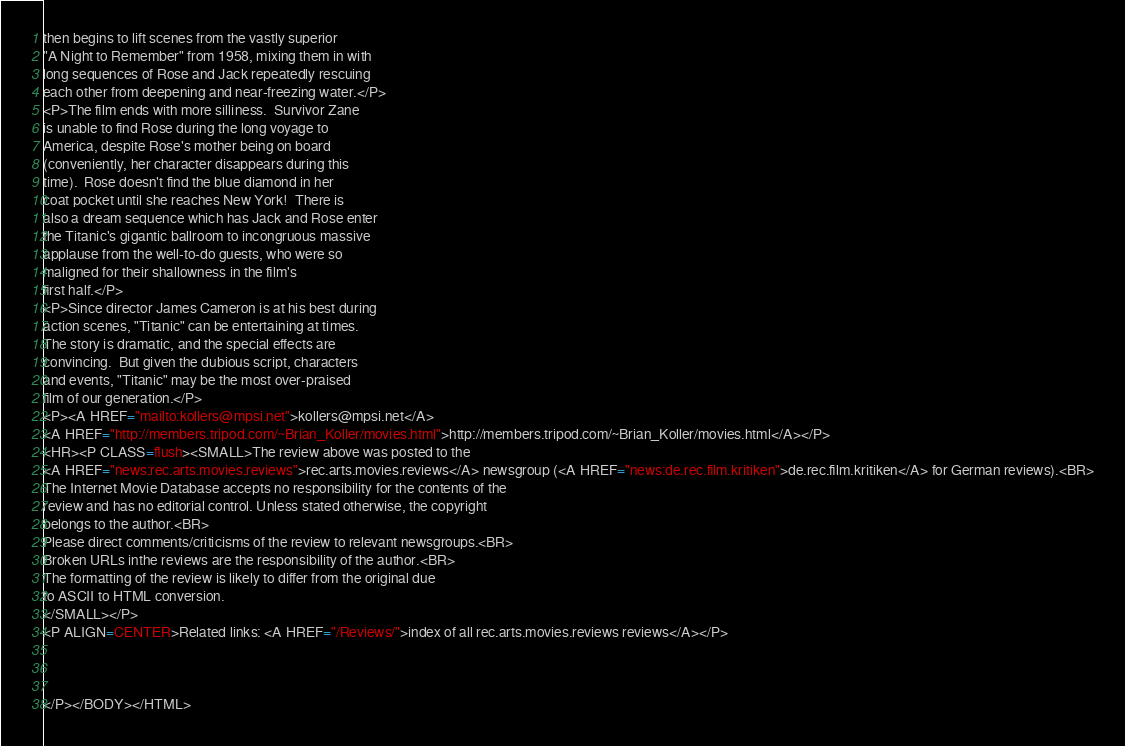<code> <loc_0><loc_0><loc_500><loc_500><_HTML_>then begins to lift scenes from the vastly superior
"A Night to Remember" from 1958, mixing them in with
long sequences of Rose and Jack repeatedly rescuing
each other from deepening and near-freezing water.</P>
<P>The film ends with more silliness.  Survivor Zane
is unable to find Rose during the long voyage to
America, despite Rose's mother being on board
(conveniently, her character disappears during this
time).  Rose doesn't find the blue diamond in her
coat pocket until she reaches New York!  There is
also a dream sequence which has Jack and Rose enter
the Titanic's gigantic ballroom to incongruous massive
applause from the well-to-do guests, who were so
maligned for their shallowness in the film's
first half.</P>
<P>Since director James Cameron is at his best during
action scenes, "Titanic" can be entertaining at times.
The story is dramatic, and the special effects are
convincing.  But given the dubious script, characters
and events, "Titanic" may be the most over-praised
film of our generation.</P>
<P><A HREF="mailto:kollers@mpsi.net">kollers@mpsi.net</A>
<A HREF="http://members.tripod.com/~Brian_Koller/movies.html">http://members.tripod.com/~Brian_Koller/movies.html</A></P>
<HR><P CLASS=flush><SMALL>The review above was posted to the
<A HREF="news:rec.arts.movies.reviews">rec.arts.movies.reviews</A> newsgroup (<A HREF="news:de.rec.film.kritiken">de.rec.film.kritiken</A> for German reviews).<BR>
The Internet Movie Database accepts no responsibility for the contents of the
review and has no editorial control. Unless stated otherwise, the copyright
belongs to the author.<BR>
Please direct comments/criticisms of the review to relevant newsgroups.<BR>
Broken URLs inthe reviews are the responsibility of the author.<BR>
The formatting of the review is likely to differ from the original due
to ASCII to HTML conversion.
</SMALL></P>
<P ALIGN=CENTER>Related links: <A HREF="/Reviews/">index of all rec.arts.movies.reviews reviews</A></P>



</P></BODY></HTML>
</code> 